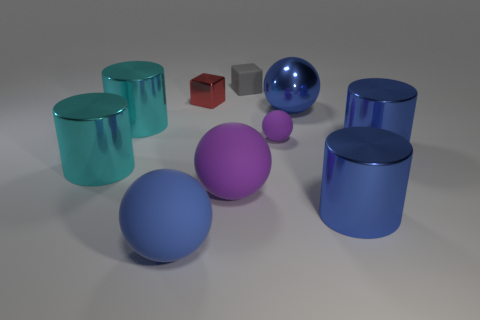There is a metallic object that is behind the blue ball behind the blue matte object; what shape is it?
Your answer should be compact. Cube. Do the big metal thing in front of the big purple sphere and the small metallic block have the same color?
Provide a short and direct response. No. What color is the thing that is both in front of the big purple object and on the left side of the red cube?
Keep it short and to the point. Blue. Is there a purple ball that has the same material as the small purple thing?
Give a very brief answer. Yes. What is the size of the gray rubber block?
Your answer should be compact. Small. There is a blue thing that is to the left of the small metal object that is in front of the small gray thing; what size is it?
Make the answer very short. Large. What material is the tiny thing that is the same shape as the large purple rubber object?
Make the answer very short. Rubber. How many cyan objects are there?
Provide a succinct answer. 2. What is the color of the cylinder right of the large blue metallic thing that is in front of the purple ball that is to the left of the small gray thing?
Provide a succinct answer. Blue. Is the number of big cyan objects less than the number of big purple matte spheres?
Provide a short and direct response. No. 